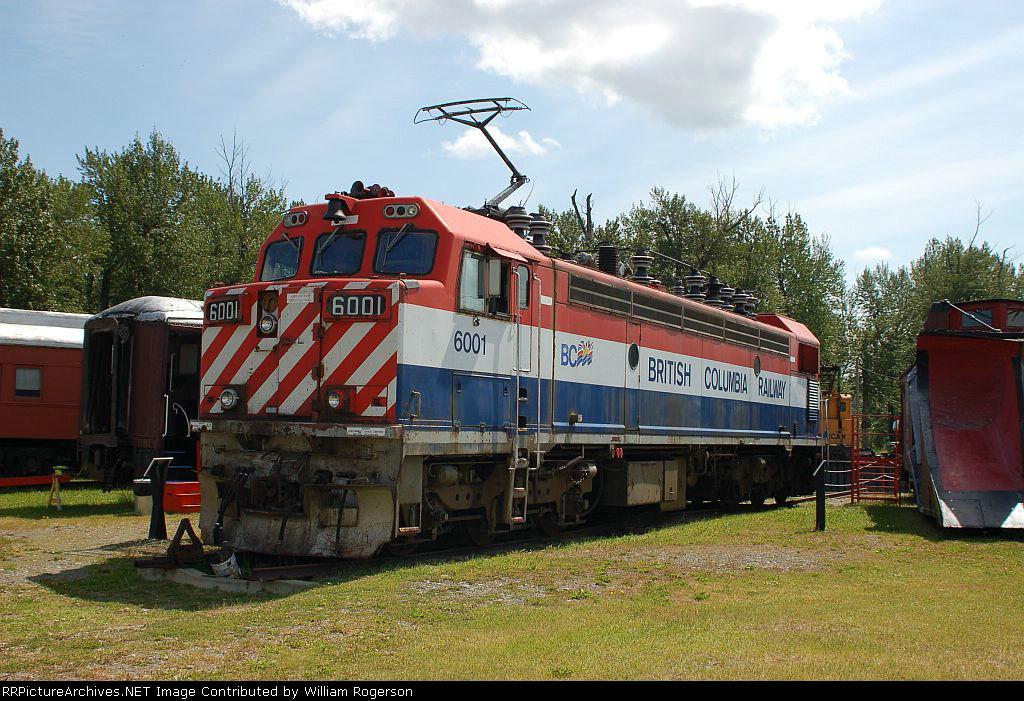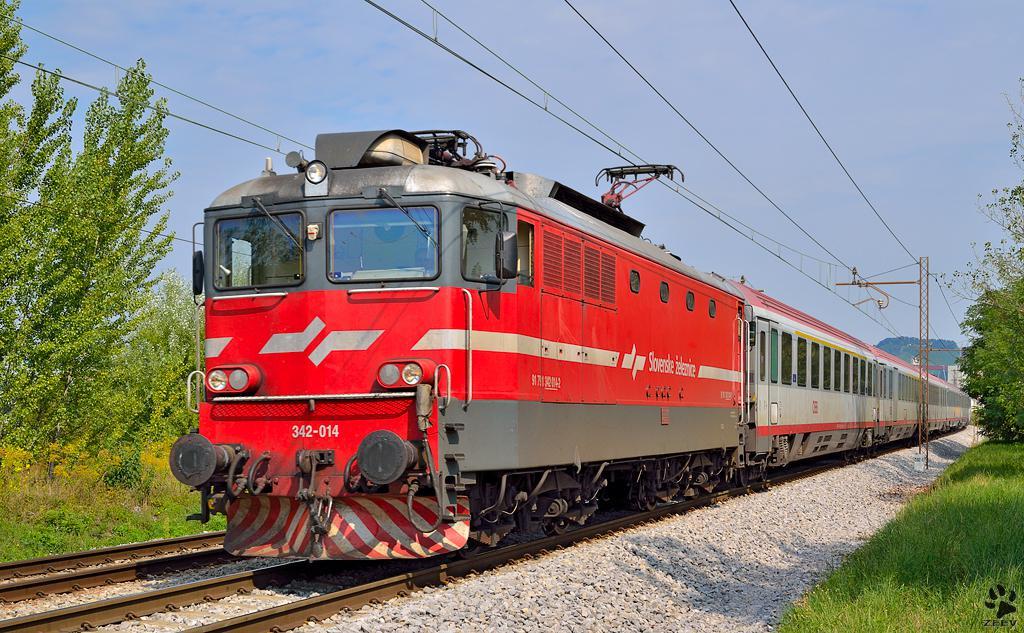The first image is the image on the left, the second image is the image on the right. Given the left and right images, does the statement "Both trains are red, white, and blue." hold true? Answer yes or no. No. The first image is the image on the left, the second image is the image on the right. Assess this claim about the two images: "Each image shows a red-topped train with white and blue stripes running horizontally along the side.". Correct or not? Answer yes or no. No. 